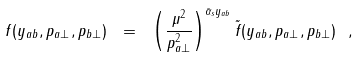<formula> <loc_0><loc_0><loc_500><loc_500>f ( y _ { a b } , \boldmath p _ { a \perp } , \boldmath p _ { b \perp } ) \ = \ \left ( { \frac { \mu ^ { 2 } } { p _ { a \perp } ^ { 2 } } } \right ) ^ { \bar { \alpha } _ { s } y _ { a b } } \tilde { f } ( y _ { a b } , \boldmath p _ { a \perp } , \boldmath p _ { b \perp } ) \ ,</formula> 